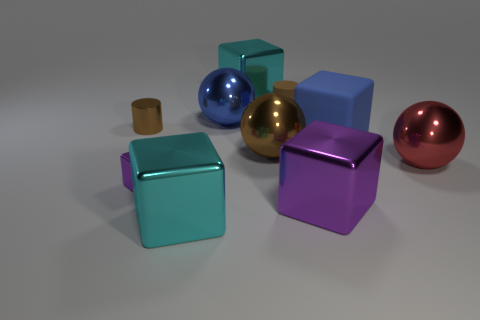Can you describe all the different colors of the objects in the image? Certainly! The image showcases a variety of objects with different colors and finishes. There's a glossy blue sphere, a matte gold ball, and a shiny pink one. The cubes exhibit different hues, including a turquoise-like teal, a solid blue, a royal purple, and a more subdued mauve. Lastly, we have a small, matte cylinder with a brownish tint resembling the color of unpolished bronze. 